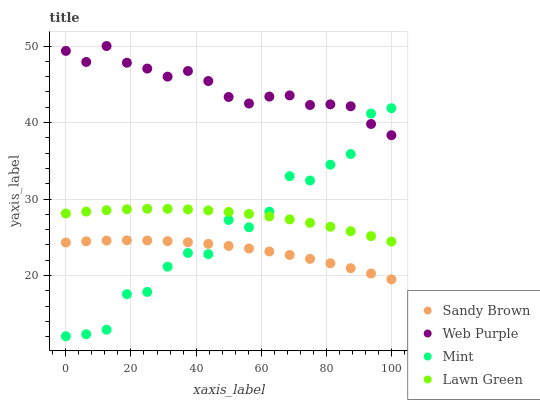Does Sandy Brown have the minimum area under the curve?
Answer yes or no. Yes. Does Web Purple have the maximum area under the curve?
Answer yes or no. Yes. Does Web Purple have the minimum area under the curve?
Answer yes or no. No. Does Sandy Brown have the maximum area under the curve?
Answer yes or no. No. Is Sandy Brown the smoothest?
Answer yes or no. Yes. Is Mint the roughest?
Answer yes or no. Yes. Is Web Purple the smoothest?
Answer yes or no. No. Is Web Purple the roughest?
Answer yes or no. No. Does Mint have the lowest value?
Answer yes or no. Yes. Does Sandy Brown have the lowest value?
Answer yes or no. No. Does Web Purple have the highest value?
Answer yes or no. Yes. Does Sandy Brown have the highest value?
Answer yes or no. No. Is Lawn Green less than Web Purple?
Answer yes or no. Yes. Is Lawn Green greater than Sandy Brown?
Answer yes or no. Yes. Does Mint intersect Sandy Brown?
Answer yes or no. Yes. Is Mint less than Sandy Brown?
Answer yes or no. No. Is Mint greater than Sandy Brown?
Answer yes or no. No. Does Lawn Green intersect Web Purple?
Answer yes or no. No. 